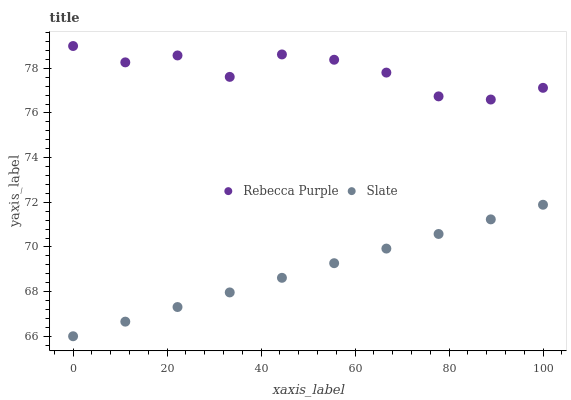Does Slate have the minimum area under the curve?
Answer yes or no. Yes. Does Rebecca Purple have the maximum area under the curve?
Answer yes or no. Yes. Does Rebecca Purple have the minimum area under the curve?
Answer yes or no. No. Is Slate the smoothest?
Answer yes or no. Yes. Is Rebecca Purple the roughest?
Answer yes or no. Yes. Is Rebecca Purple the smoothest?
Answer yes or no. No. Does Slate have the lowest value?
Answer yes or no. Yes. Does Rebecca Purple have the lowest value?
Answer yes or no. No. Does Rebecca Purple have the highest value?
Answer yes or no. Yes. Is Slate less than Rebecca Purple?
Answer yes or no. Yes. Is Rebecca Purple greater than Slate?
Answer yes or no. Yes. Does Slate intersect Rebecca Purple?
Answer yes or no. No. 